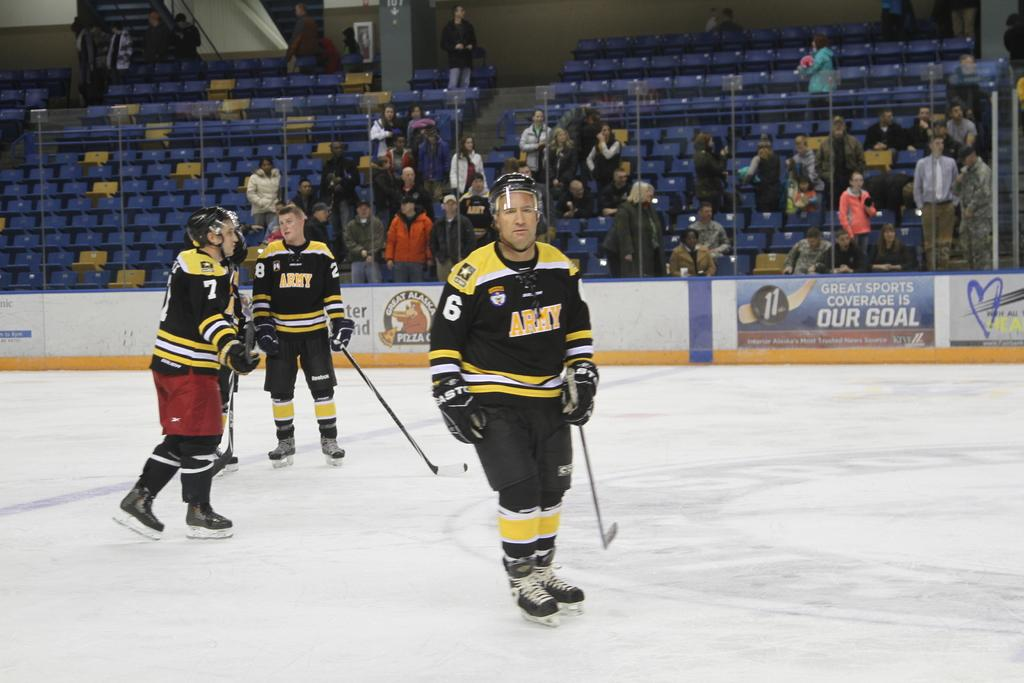How many people are in the image? There are three people in the image. What are the people wearing? The people are wearing sports dress. What sport are the people playing? The people are playing ice hockey. What equipment are the people using to play ice hockey? The people are holding hockey sticks. Can you describe the background of the image? There are other people visible in the background of the image. How many dolls are sitting on the ice during the ice hockey game? There are no dolls present in the image; it features three people playing ice hockey. What type of nose is visible on the ice during the ice hockey game? There is no nose visible on the ice during the ice hockey game; the image only shows people playing the sport. 